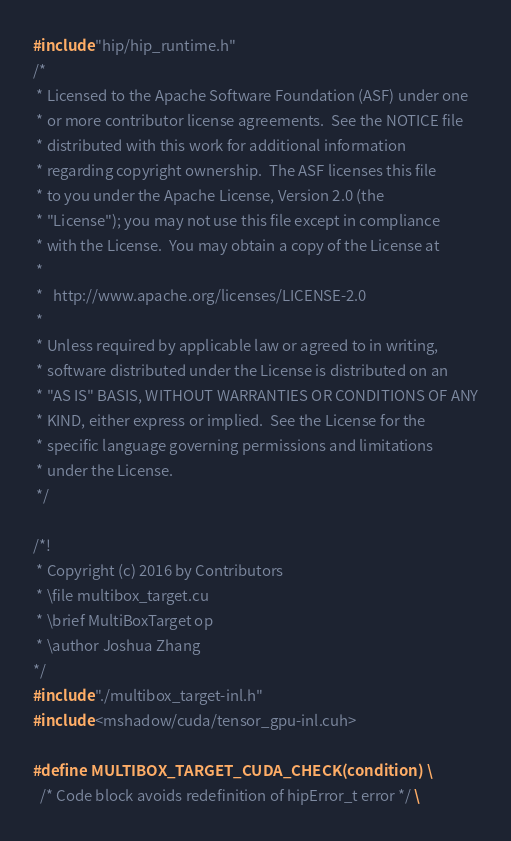Convert code to text. <code><loc_0><loc_0><loc_500><loc_500><_Cuda_>#include "hip/hip_runtime.h"
/*
 * Licensed to the Apache Software Foundation (ASF) under one
 * or more contributor license agreements.  See the NOTICE file
 * distributed with this work for additional information
 * regarding copyright ownership.  The ASF licenses this file
 * to you under the Apache License, Version 2.0 (the
 * "License"); you may not use this file except in compliance
 * with the License.  You may obtain a copy of the License at
 *
 *   http://www.apache.org/licenses/LICENSE-2.0
 *
 * Unless required by applicable law or agreed to in writing,
 * software distributed under the License is distributed on an
 * "AS IS" BASIS, WITHOUT WARRANTIES OR CONDITIONS OF ANY
 * KIND, either express or implied.  See the License for the
 * specific language governing permissions and limitations
 * under the License.
 */

/*!
 * Copyright (c) 2016 by Contributors
 * \file multibox_target.cu
 * \brief MultiBoxTarget op
 * \author Joshua Zhang
*/
#include "./multibox_target-inl.h"
#include <mshadow/cuda/tensor_gpu-inl.cuh>

#define MULTIBOX_TARGET_CUDA_CHECK(condition) \
  /* Code block avoids redefinition of hipError_t error */ \</code> 